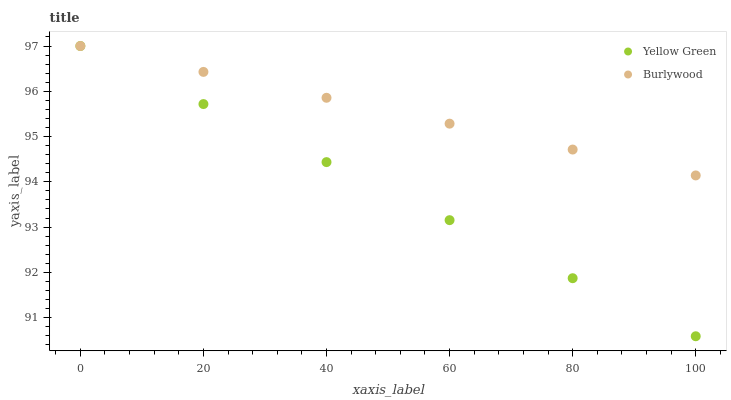Does Yellow Green have the minimum area under the curve?
Answer yes or no. Yes. Does Burlywood have the maximum area under the curve?
Answer yes or no. Yes. Does Yellow Green have the maximum area under the curve?
Answer yes or no. No. Is Yellow Green the smoothest?
Answer yes or no. Yes. Is Burlywood the roughest?
Answer yes or no. Yes. Is Yellow Green the roughest?
Answer yes or no. No. Does Yellow Green have the lowest value?
Answer yes or no. Yes. Does Yellow Green have the highest value?
Answer yes or no. Yes. Does Yellow Green intersect Burlywood?
Answer yes or no. Yes. Is Yellow Green less than Burlywood?
Answer yes or no. No. Is Yellow Green greater than Burlywood?
Answer yes or no. No. 